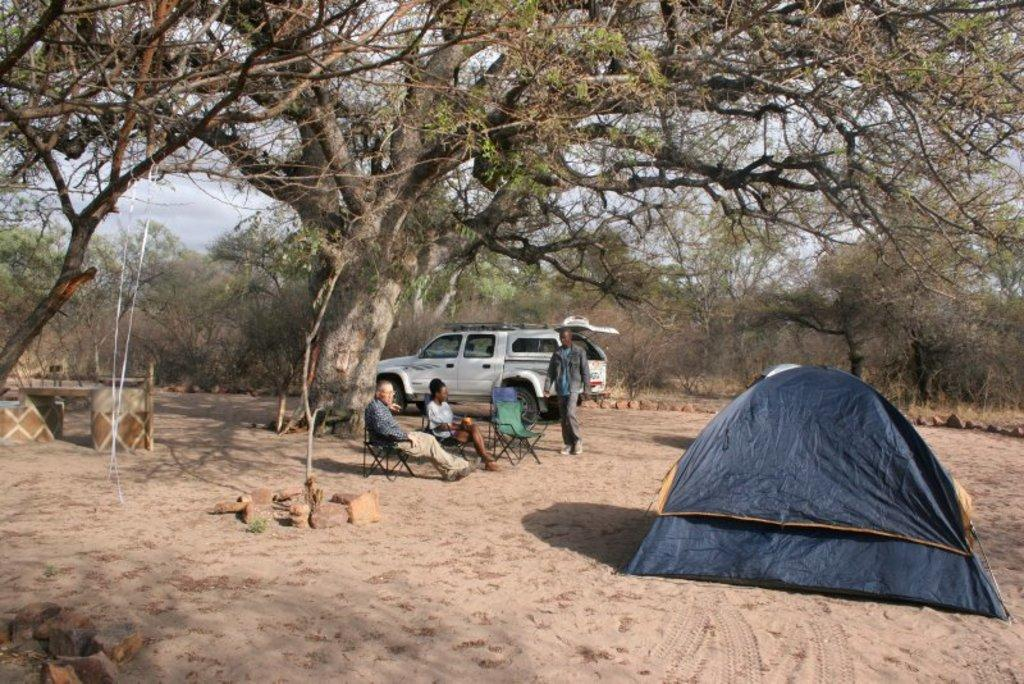What are the two people in the center of the image doing? The two people are sitting on chairs in the center of the image. What is the man in the image doing? The man is walking in the image. What structure can be seen on the right side of the image? There is a tent on the right side of the image. What can be seen in the background of the image? There is a car and trees visible in the background of the image, as well as the sky. How many children are sitting on the lumber in the image? There is no lumber or children present in the image. What is the man in the image doing with his mouth? There is no information about the man's mouth in the image. 